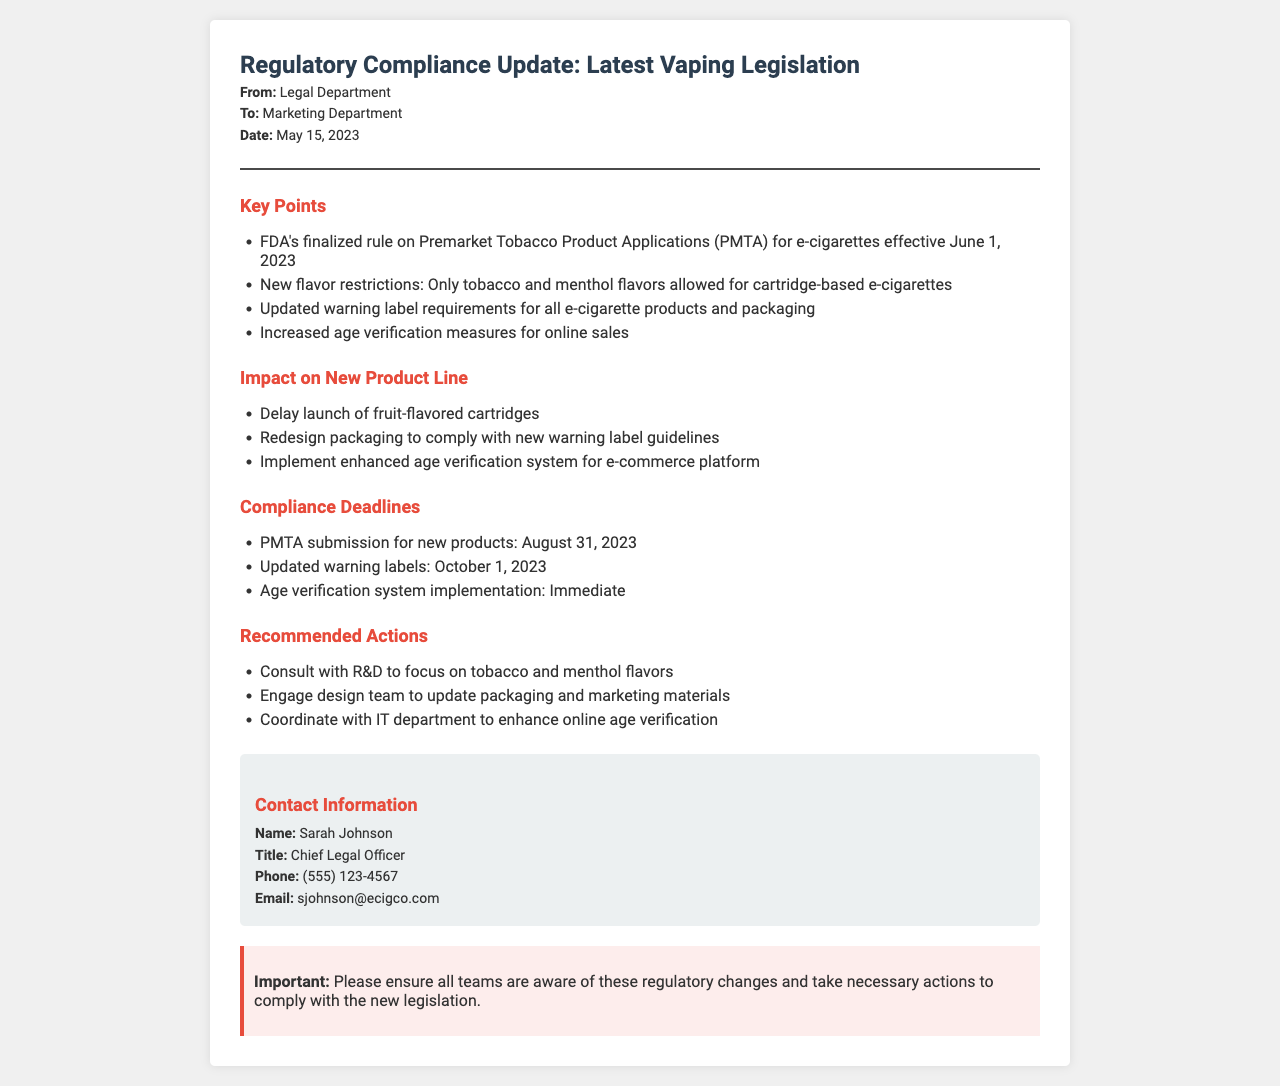What is the effective date of the FDA's finalized rule? The effective date for the FDA's finalized rule on PMTA for e-cigarettes is clearly stated in the document as June 1, 2023.
Answer: June 1, 2023 What flavors are now allowed for cartridge-based e-cigarettes? The document specifies that only tobacco and menthol flavors are allowed for cartridge-based e-cigarettes.
Answer: Tobacco and menthol When is the deadline for PMTA submission for new products? The deadline for PMTA submission is mentioned in the compliance deadlines section. The document states August 31, 2023, as the date.
Answer: August 31, 2023 Who is the contact person listed in the fax? The document includes contact information for Sarah Johnson, who is the Chief Legal Officer.
Answer: Sarah Johnson What is one recommended action regarding flavors? One of the recommended actions is to consult with R&D to focus on tobacco and menthol flavors, emphasizing the need to adapt to new regulations.
Answer: Consult with R&D What should be redesigned to comply with new regulations? The document mentions that the packaging needs to be redesigned to comply with new warning label guidelines.
Answer: Packaging What is required for online sales according to the document? The document highlights that there are increased age verification measures required for online sales as part of the new regulations.
Answer: Age verification What is the immediate compliance action mentioned in the compliance deadlines? The document states that the implementation of the age verification system is required immediately as part of compliance actions.
Answer: Immediate What color is used in the header of the document? The header of the document uses a color scheme describing the header text color, which is noted as #2c3e50, a dark blue tone.
Answer: Dark blue 